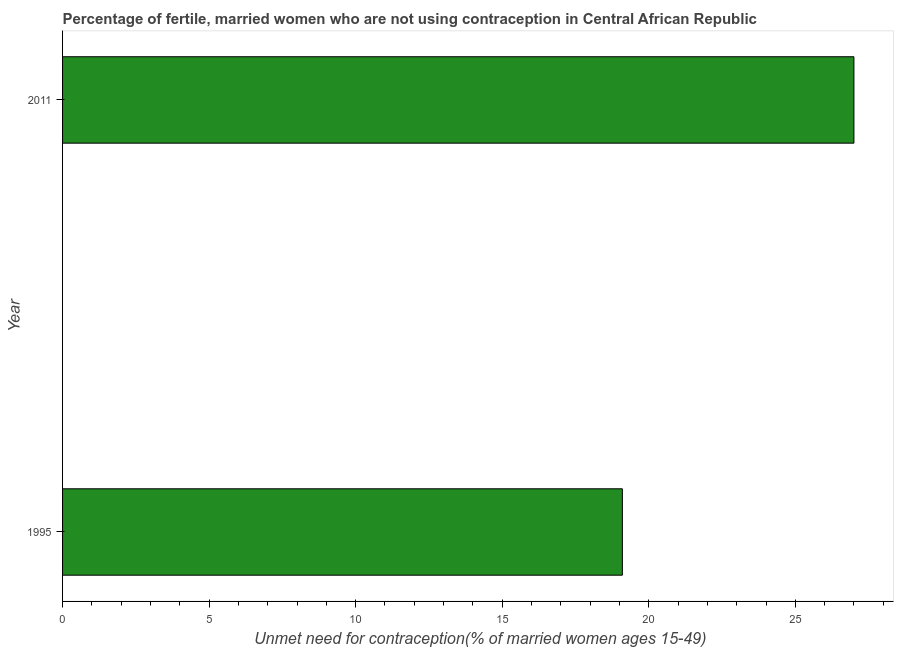Does the graph contain grids?
Your answer should be compact. No. What is the title of the graph?
Offer a very short reply. Percentage of fertile, married women who are not using contraception in Central African Republic. What is the label or title of the X-axis?
Your answer should be compact.  Unmet need for contraception(% of married women ages 15-49). What is the number of married women who are not using contraception in 1995?
Give a very brief answer. 19.1. Across all years, what is the maximum number of married women who are not using contraception?
Your answer should be compact. 27. What is the sum of the number of married women who are not using contraception?
Keep it short and to the point. 46.1. What is the difference between the number of married women who are not using contraception in 1995 and 2011?
Ensure brevity in your answer.  -7.9. What is the average number of married women who are not using contraception per year?
Your response must be concise. 23.05. What is the median number of married women who are not using contraception?
Make the answer very short. 23.05. Do a majority of the years between 2011 and 1995 (inclusive) have number of married women who are not using contraception greater than 14 %?
Keep it short and to the point. No. What is the ratio of the number of married women who are not using contraception in 1995 to that in 2011?
Your answer should be very brief. 0.71. Is the number of married women who are not using contraception in 1995 less than that in 2011?
Provide a succinct answer. Yes. In how many years, is the number of married women who are not using contraception greater than the average number of married women who are not using contraception taken over all years?
Your answer should be compact. 1. How many bars are there?
Ensure brevity in your answer.  2. Are all the bars in the graph horizontal?
Make the answer very short. Yes. How many years are there in the graph?
Offer a very short reply. 2. What is the ratio of the  Unmet need for contraception(% of married women ages 15-49) in 1995 to that in 2011?
Ensure brevity in your answer.  0.71. 